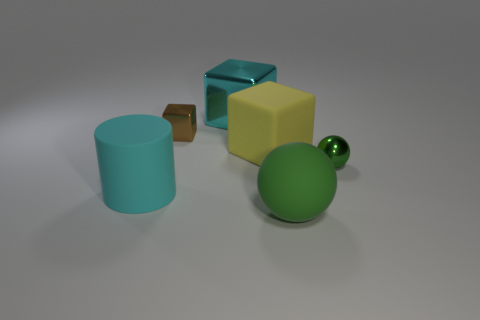Add 2 big blue shiny cylinders. How many objects exist? 8 Subtract all big cyan shiny cubes. Subtract all yellow rubber objects. How many objects are left? 4 Add 1 cyan matte objects. How many cyan matte objects are left? 2 Add 4 tiny green metal things. How many tiny green metal things exist? 5 Subtract 0 brown cylinders. How many objects are left? 6 Subtract all cylinders. How many objects are left? 5 